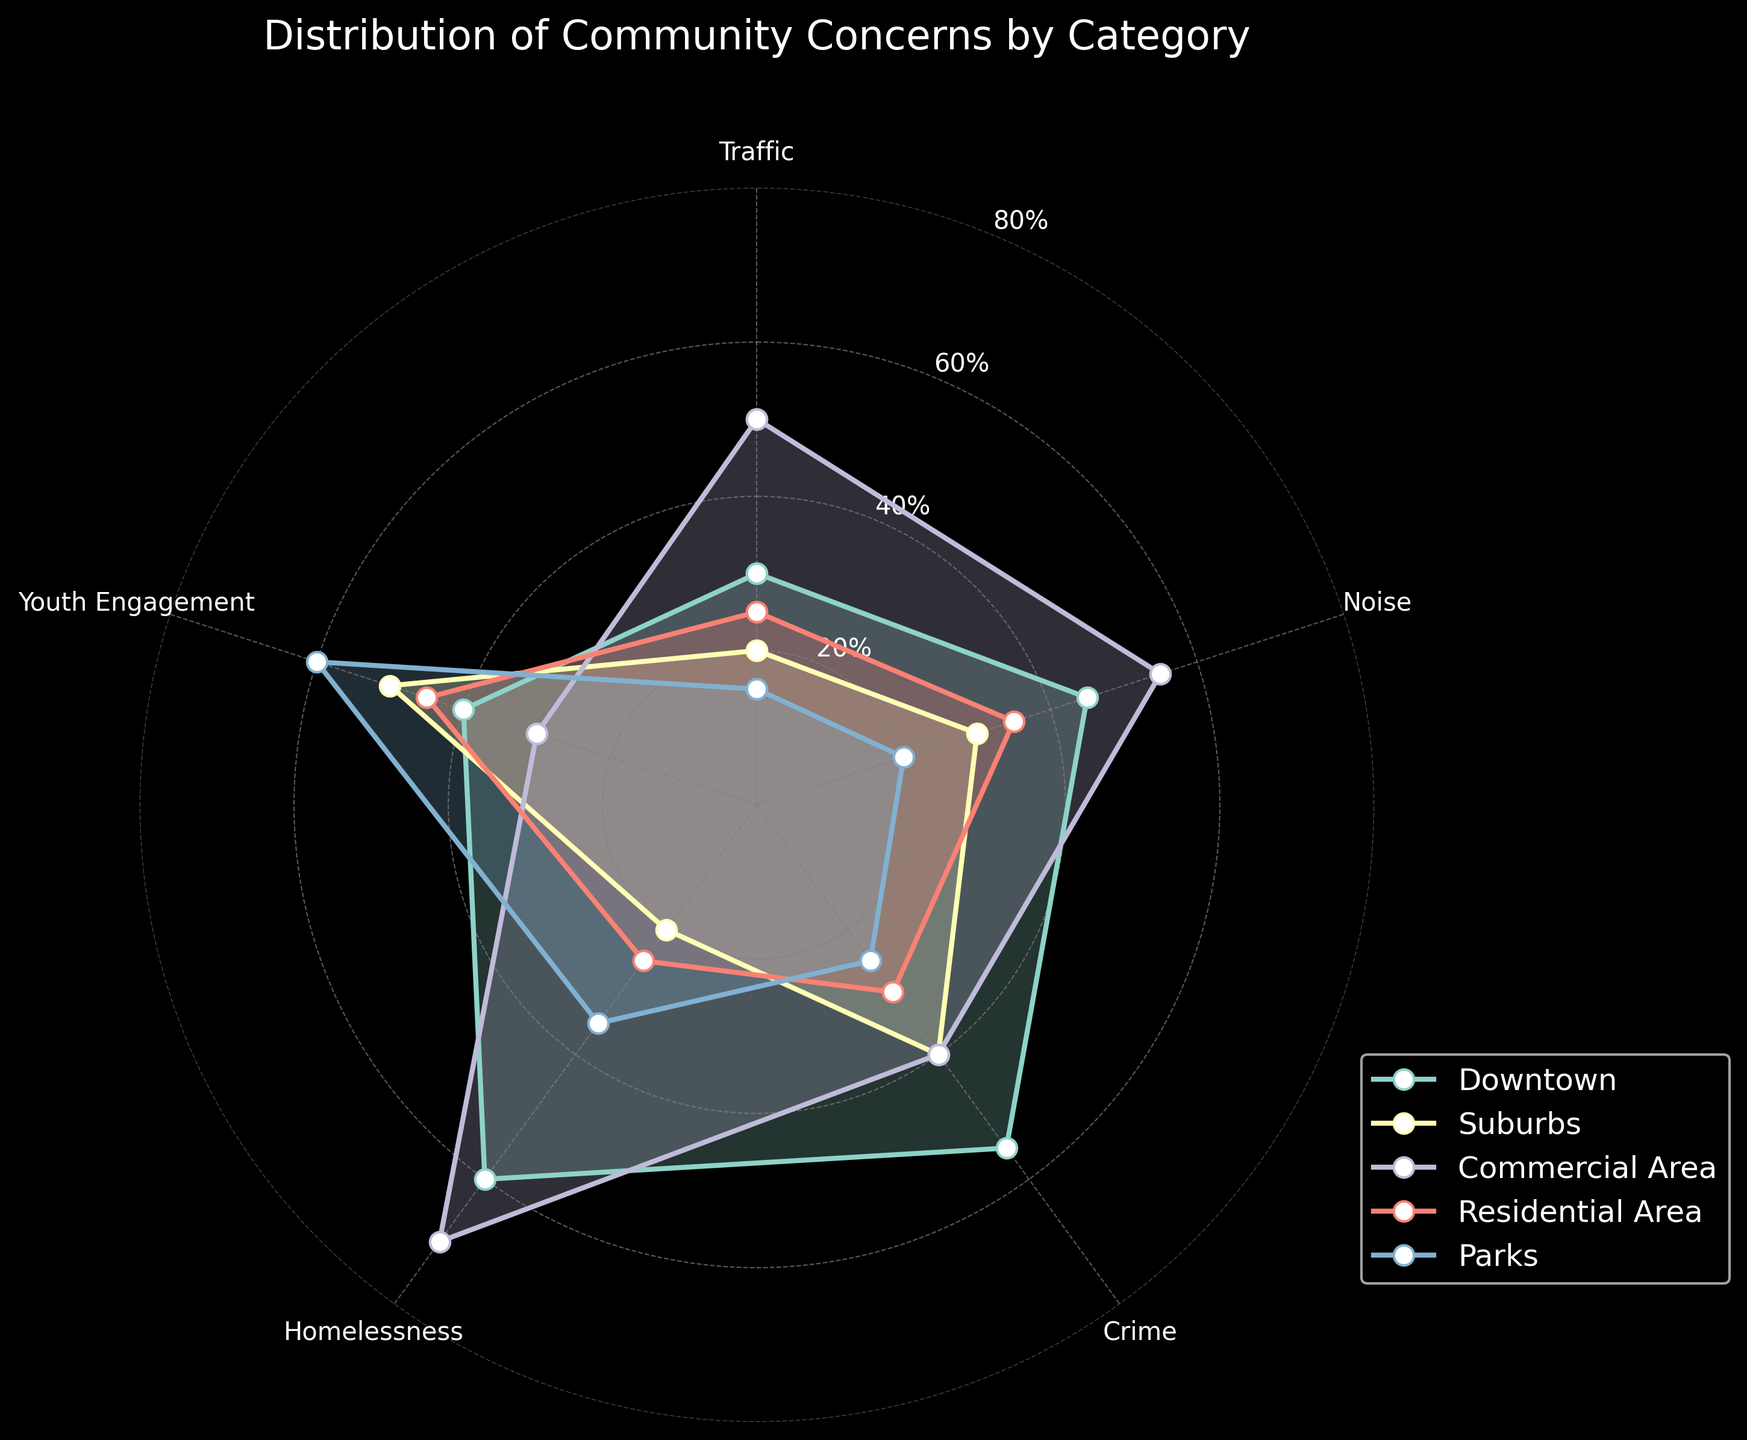What's the title of the radar chart? The title is typically placed at the top of the chart and serves as a summary of the main information being displayed. In this case, you can see the title "Distribution of Community Concerns by Category" positioned prominently.
Answer: Distribution of Community Concerns by Category How many categories are being compared in the radar chart? Count the number of different sections along the perimeter of the radar chart which are labeled. There are five labels: Traffic, Noise, Crime, Homelessness, and Youth Engagement.
Answer: Five Which area is most concerned about homelessness? Look at the values along the Homelessness axis and identify which area has the highest value. Downtown has a value of 60, Suburbs has 20, Commercial Area has 70, Residential Area has 25, and Parks has 35. Commercial Area has the highest value.
Answer: Commercial Area What is the difference in youth engagement concerns between Parks and Suburbs? Identify the values for youth engagement in Parks and Suburbs. Parks have a value of 60 and Suburbs have a value of 50. The difference is 60 - 50 = 10.
Answer: 10 Which category has the least concern in every area? Examine the values for each category across all areas and identify the category with the smallest values. Traffic generally has lower values compared to other categories across different areas.
Answer: Traffic Compare the crime concerns in Downtown and Residential Area. Which area has higher concerns? Identify the values for crime in these two areas. Downtown has a value of 55 and Residential Area has a value of 30. Downtown has the higher concern.
Answer: Downtown What are the different community areas analyzed in the chart? Look at the labels used in the legend of the radar chart. The community areas analyzed include Downtown, Suburbs, Commercial Area, Residential Area, and Parks.
Answer: Downtown, Suburbs, Commercial Area, Residential Area, Parks Which two areas have the closest levels of noise concerns? Compare the noise concern values across different areas. Downtown has 45, Suburbs has 30, Commercial Area has 55, Residential Area has 35, and Parks have 20. Residential Area (35) and Suburbs (30) have the closest levels with a difference of only 5.
Answer: Residential Area and Suburbs What is the average concern for traffic across all areas? Add the traffic values for all areas and divide by the number of areas. Values: Downtown (30), Suburbs (20), Commercial Area (50), Residential Area (25), Parks (15). Sum = 30 + 20 + 50 + 25 + 15 = 140. Average = 140 / 5 = 28.
Answer: 28 